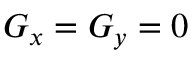<formula> <loc_0><loc_0><loc_500><loc_500>G _ { x } = G _ { y } = 0</formula> 